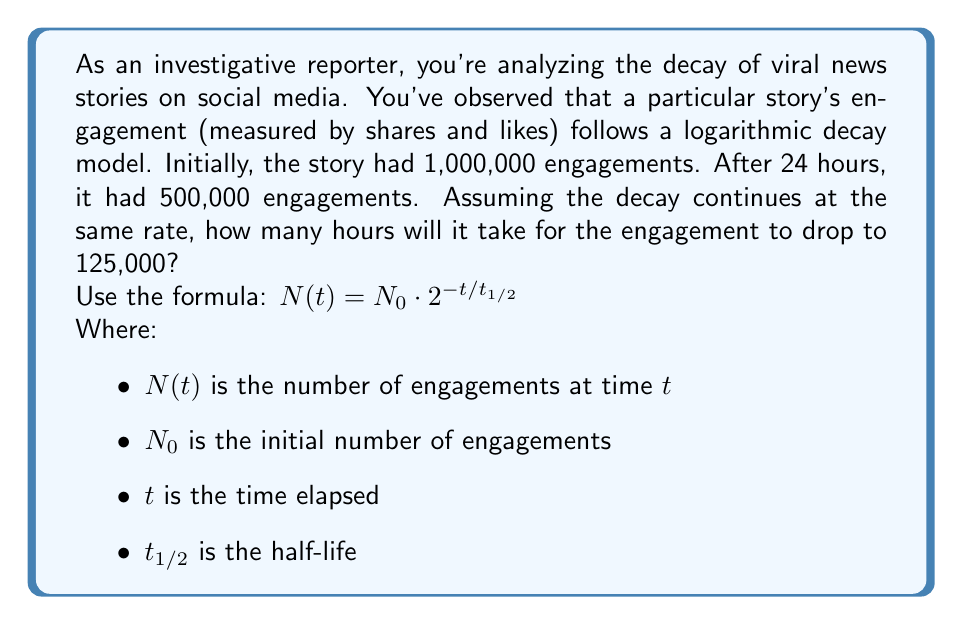Can you answer this question? To solve this problem, we'll follow these steps:

1) First, let's calculate the half-life ($t_{1/2}$) using the given information:
   $N_0 = 1,000,000$ and after 24 hours, $N(24) = 500,000$

   Using the formula: $500,000 = 1,000,000 \cdot 2^{-24/t_{1/2}}$

2) Simplify:
   $\frac{1}{2} = 2^{-24/t_{1/2}}$

3) Take the logarithm of both sides:
   $\log_2(\frac{1}{2}) = -24/t_{1/2}$

4) Solve for $t_{1/2}$:
   $t_{1/2} = \frac{-24}{\log_2(\frac{1}{2})} = 24$ hours

5) Now that we know the half-life, we can use it to find when the engagement drops to 125,000:
   $125,000 = 1,000,000 \cdot 2^{-t/24}$

6) Simplify:
   $\frac{1}{8} = 2^{-t/24}$

7) Take the logarithm of both sides:
   $\log_2(\frac{1}{8}) = -t/24$

8) Solve for $t$:
   $t = -24 \cdot \log_2(\frac{1}{8}) = 72$ hours
Answer: It will take 72 hours for the engagement to drop to 125,000. 